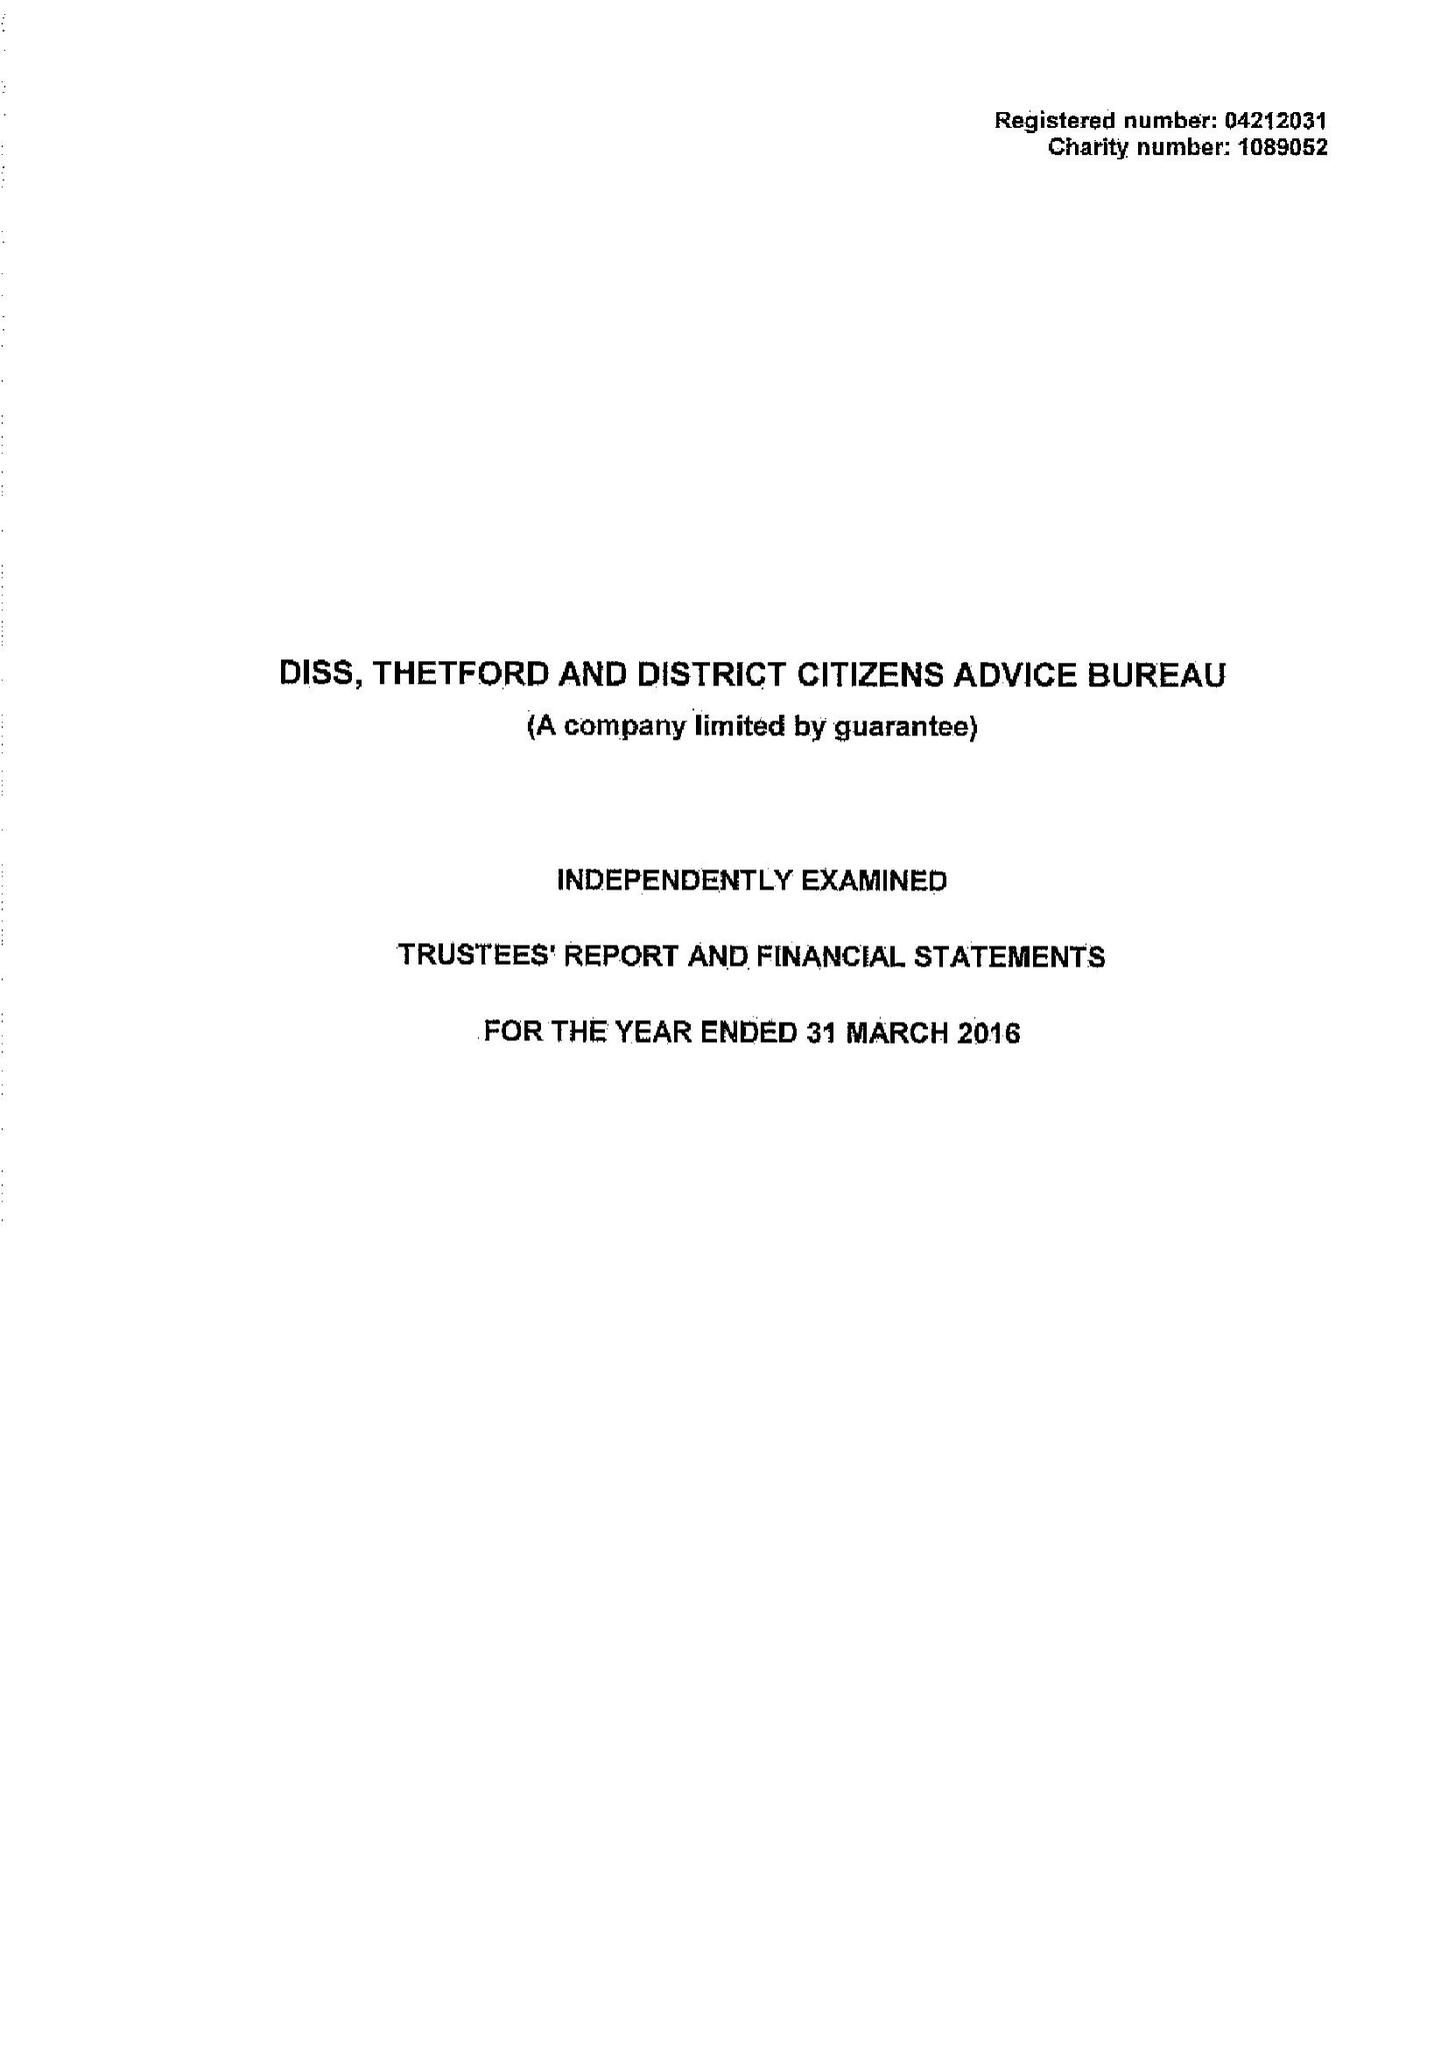What is the value for the spending_annually_in_british_pounds?
Answer the question using a single word or phrase. 628747.00 